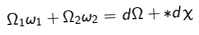Convert formula to latex. <formula><loc_0><loc_0><loc_500><loc_500>\Omega _ { 1 } \omega _ { 1 } + \Omega _ { 2 } \omega _ { 2 } = d \Omega + \ast d \chi</formula> 